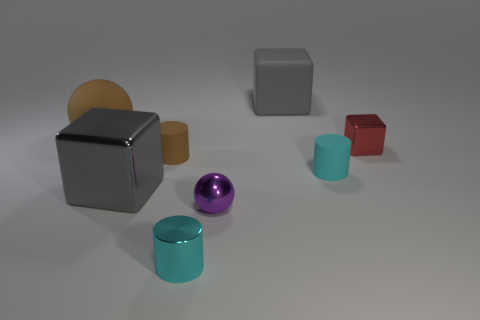How many tiny shiny balls are there?
Ensure brevity in your answer.  1. There is a large matte thing that is in front of the large rubber block; is its color the same as the metallic block to the left of the brown cylinder?
Give a very brief answer. No. What is the size of the rubber cylinder that is the same color as the small metal cylinder?
Provide a succinct answer. Small. What number of other things are the same size as the brown rubber sphere?
Provide a short and direct response. 2. There is a cylinder left of the tiny shiny cylinder; what is its color?
Provide a succinct answer. Brown. Does the brown object left of the brown cylinder have the same material as the small red object?
Offer a terse response. No. How many large cubes are in front of the cyan matte thing and behind the big sphere?
Provide a short and direct response. 0. What is the color of the big thing that is in front of the metallic block that is on the right side of the small cyan rubber thing behind the metal cylinder?
Offer a very short reply. Gray. How many other objects are the same shape as the red shiny object?
Make the answer very short. 2. There is a gray object that is to the right of the metallic cylinder; is there a big gray cube that is in front of it?
Your answer should be very brief. Yes. 